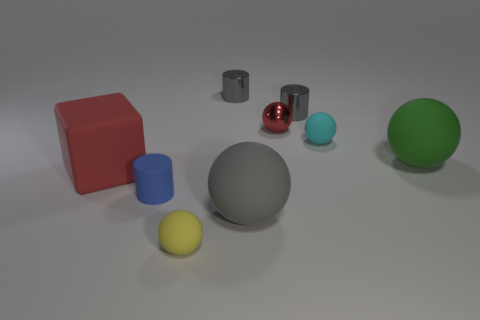Subtract all yellow spheres. How many spheres are left? 4 Subtract all cyan rubber balls. How many balls are left? 4 Subtract 1 spheres. How many spheres are left? 4 Subtract all blue spheres. Subtract all blue cylinders. How many spheres are left? 5 Add 1 small cylinders. How many objects exist? 10 Subtract all cylinders. How many objects are left? 6 Subtract all red matte blocks. Subtract all small cyan spheres. How many objects are left? 7 Add 6 large matte things. How many large matte things are left? 9 Add 8 gray cylinders. How many gray cylinders exist? 10 Subtract 0 blue cubes. How many objects are left? 9 